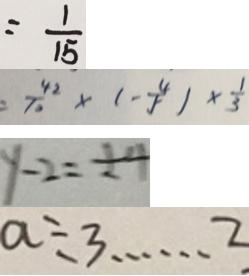<formula> <loc_0><loc_0><loc_500><loc_500>= \frac { 1 } { 1 5 } 
 = \frac { 4 2 } { 1 0 } \times ( - \frac { 4 } { 5 } ) \times \frac { 1 } { 3 } 
 y - 2 = \pm 4 
 a \div 3 \cdots 2</formula> 